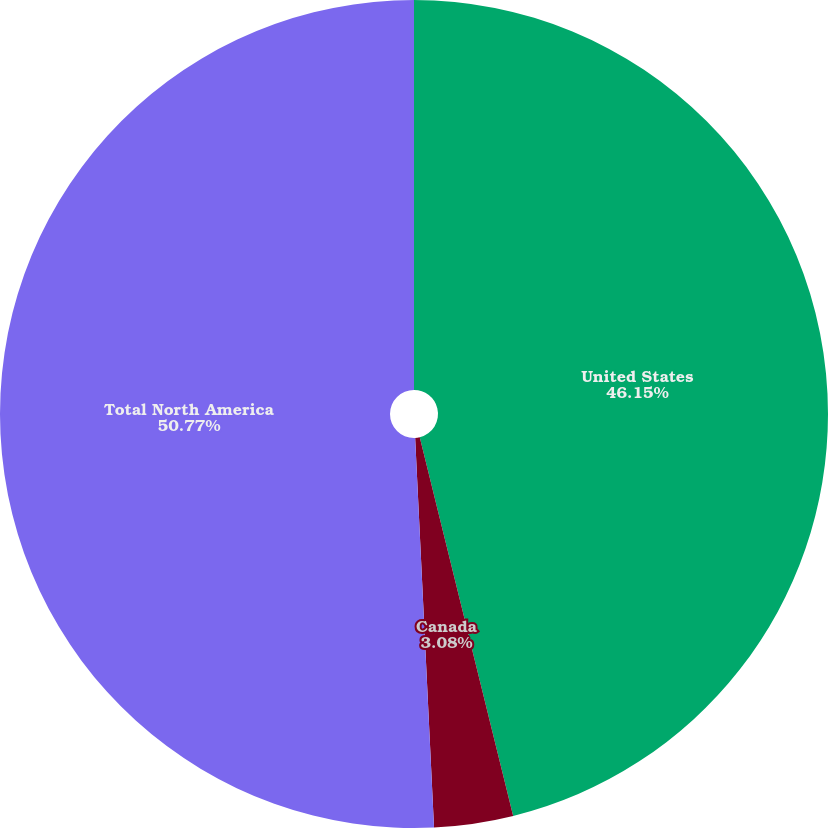Convert chart. <chart><loc_0><loc_0><loc_500><loc_500><pie_chart><fcel>United States<fcel>Canada<fcel>Total North America<nl><fcel>46.15%<fcel>3.08%<fcel>50.77%<nl></chart> 